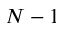Convert formula to latex. <formula><loc_0><loc_0><loc_500><loc_500>N - 1</formula> 